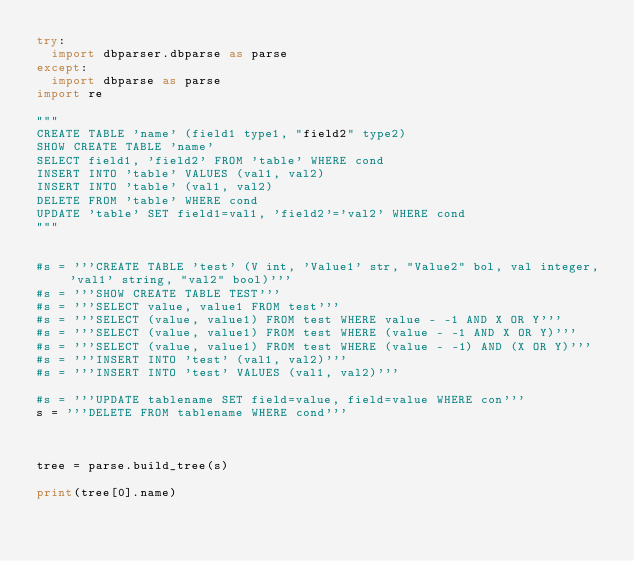Convert code to text. <code><loc_0><loc_0><loc_500><loc_500><_Python_>try:
	import dbparser.dbparse as parse
except:
	import dbparse as parse
import re

"""
CREATE TABLE 'name' (field1 type1, "field2" type2)
SHOW CREATE TABLE 'name'
SELECT field1, 'field2' FROM 'table' WHERE cond
INSERT INTO 'table' VALUES (val1, val2)
INSERT INTO 'table' (val1, val2)
DELETE FROM 'table' WHERE cond
UPDATE 'table' SET field1=val1, 'field2'='val2' WHERE cond
"""


#s = '''CREATE TABLE 'test' (V int, 'Value1' str, "Value2" bol, val integer, 'val1' string, "val2" bool)'''
#s = '''SHOW CREATE TABLE TEST'''
#s = '''SELECT value, value1 FROM test'''
#s = '''SELECT (value, value1) FROM test WHERE value - -1 AND X OR Y'''
#s = '''SELECT (value, value1) FROM test WHERE (value - -1 AND X OR Y)'''
#s = '''SELECT (value, value1) FROM test WHERE (value - -1) AND (X OR Y)'''
#s = '''INSERT INTO 'test' (val1, val2)'''
#s = '''INSERT INTO 'test' VALUES (val1, val2)'''

#s = '''UPDATE tablename SET field=value, field=value WHERE con'''
s = '''DELETE FROM tablename WHERE cond'''



tree = parse.build_tree(s)

print(tree[0].name)






</code> 